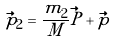Convert formula to latex. <formula><loc_0><loc_0><loc_500><loc_500>\vec { p } _ { 2 } = \frac { m _ { 2 } } { M } \vec { P } + \vec { p }</formula> 